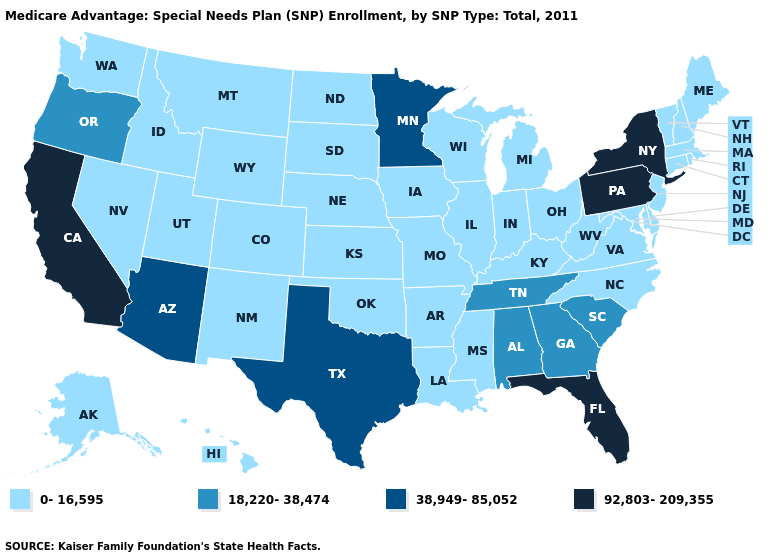Does California have the highest value in the West?
Keep it brief. Yes. What is the highest value in the USA?
Quick response, please. 92,803-209,355. Name the states that have a value in the range 18,220-38,474?
Answer briefly. Alabama, Georgia, Oregon, South Carolina, Tennessee. Does Arkansas have the lowest value in the USA?
Be succinct. Yes. What is the value of Maine?
Concise answer only. 0-16,595. Does the first symbol in the legend represent the smallest category?
Write a very short answer. Yes. Name the states that have a value in the range 0-16,595?
Short answer required. Alaska, Arkansas, Colorado, Connecticut, Delaware, Hawaii, Iowa, Idaho, Illinois, Indiana, Kansas, Kentucky, Louisiana, Massachusetts, Maryland, Maine, Michigan, Missouri, Mississippi, Montana, North Carolina, North Dakota, Nebraska, New Hampshire, New Jersey, New Mexico, Nevada, Ohio, Oklahoma, Rhode Island, South Dakota, Utah, Virginia, Vermont, Washington, Wisconsin, West Virginia, Wyoming. Among the states that border Alabama , which have the highest value?
Concise answer only. Florida. Does Maine have the highest value in the Northeast?
Be succinct. No. How many symbols are there in the legend?
Give a very brief answer. 4. Name the states that have a value in the range 38,949-85,052?
Keep it brief. Arizona, Minnesota, Texas. Which states have the highest value in the USA?
Answer briefly. California, Florida, New York, Pennsylvania. Does Rhode Island have the lowest value in the Northeast?
Quick response, please. Yes. Does the first symbol in the legend represent the smallest category?
Quick response, please. Yes. Name the states that have a value in the range 18,220-38,474?
Short answer required. Alabama, Georgia, Oregon, South Carolina, Tennessee. 